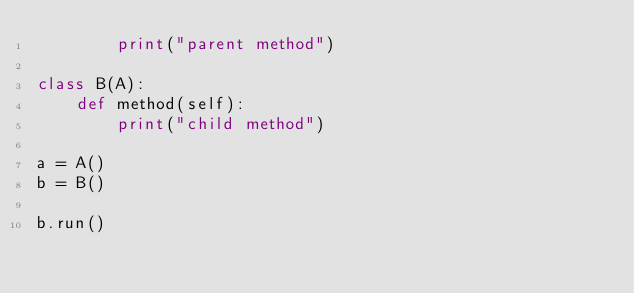<code> <loc_0><loc_0><loc_500><loc_500><_Python_>		print("parent method")

class B(A):
	def method(self):
		print("child method")

a = A()
b = B()

b.run()</code> 